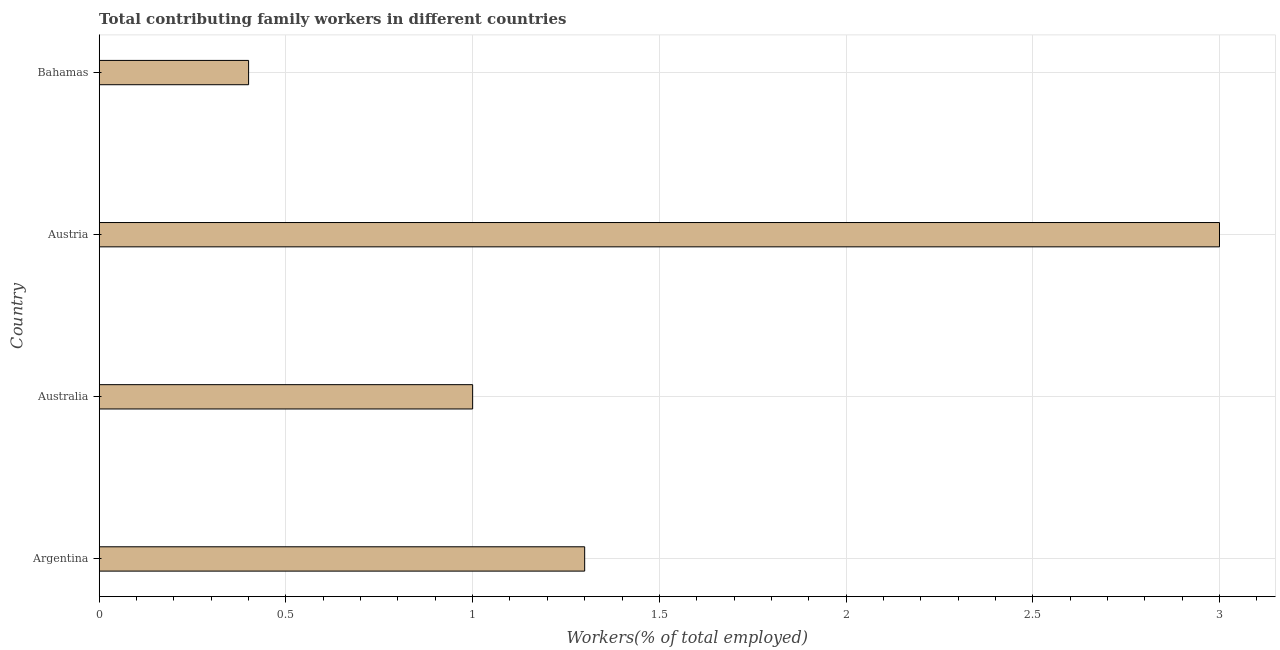Does the graph contain any zero values?
Keep it short and to the point. No. What is the title of the graph?
Make the answer very short. Total contributing family workers in different countries. What is the label or title of the X-axis?
Your answer should be compact. Workers(% of total employed). Across all countries, what is the maximum contributing family workers?
Your answer should be very brief. 3. Across all countries, what is the minimum contributing family workers?
Make the answer very short. 0.4. In which country was the contributing family workers minimum?
Your answer should be very brief. Bahamas. What is the sum of the contributing family workers?
Offer a terse response. 5.7. What is the average contributing family workers per country?
Provide a succinct answer. 1.43. What is the median contributing family workers?
Your answer should be compact. 1.15. In how many countries, is the contributing family workers greater than 1.4 %?
Give a very brief answer. 1. Is the contributing family workers in Argentina less than that in Austria?
Your response must be concise. Yes. Is the sum of the contributing family workers in Argentina and Australia greater than the maximum contributing family workers across all countries?
Keep it short and to the point. No. How many countries are there in the graph?
Your response must be concise. 4. What is the difference between two consecutive major ticks on the X-axis?
Keep it short and to the point. 0.5. Are the values on the major ticks of X-axis written in scientific E-notation?
Offer a very short reply. No. What is the Workers(% of total employed) of Argentina?
Your answer should be compact. 1.3. What is the Workers(% of total employed) of Bahamas?
Provide a short and direct response. 0.4. What is the difference between the Workers(% of total employed) in Australia and Austria?
Keep it short and to the point. -2. What is the difference between the Workers(% of total employed) in Austria and Bahamas?
Your answer should be very brief. 2.6. What is the ratio of the Workers(% of total employed) in Argentina to that in Austria?
Your answer should be compact. 0.43. What is the ratio of the Workers(% of total employed) in Australia to that in Austria?
Provide a succinct answer. 0.33. What is the ratio of the Workers(% of total employed) in Australia to that in Bahamas?
Offer a terse response. 2.5. 